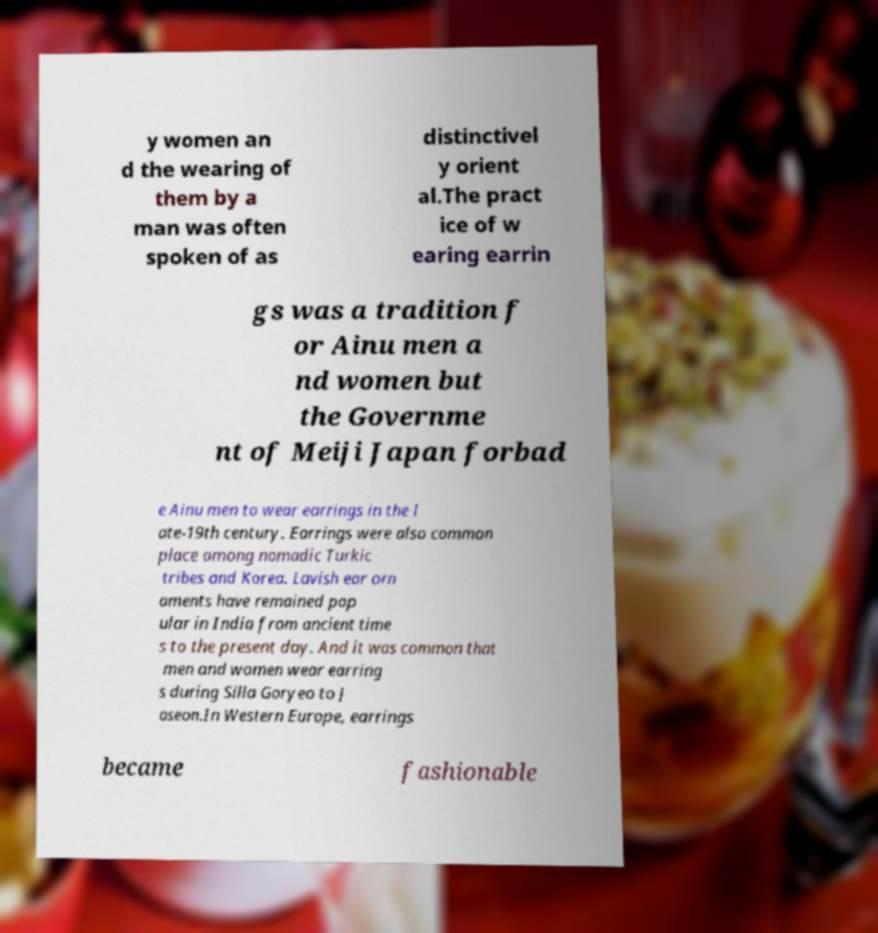Please read and relay the text visible in this image. What does it say? y women an d the wearing of them by a man was often spoken of as distinctivel y orient al.The pract ice of w earing earrin gs was a tradition f or Ainu men a nd women but the Governme nt of Meiji Japan forbad e Ainu men to wear earrings in the l ate-19th century. Earrings were also common place among nomadic Turkic tribes and Korea. Lavish ear orn aments have remained pop ular in India from ancient time s to the present day. And it was common that men and women wear earring s during Silla Goryeo to J oseon.In Western Europe, earrings became fashionable 